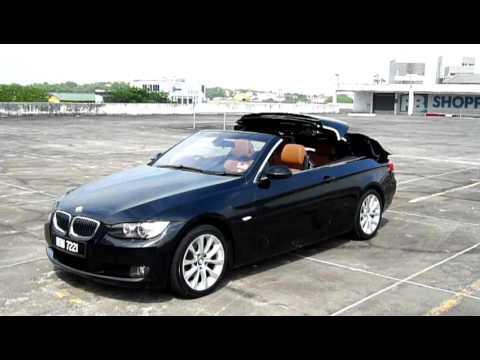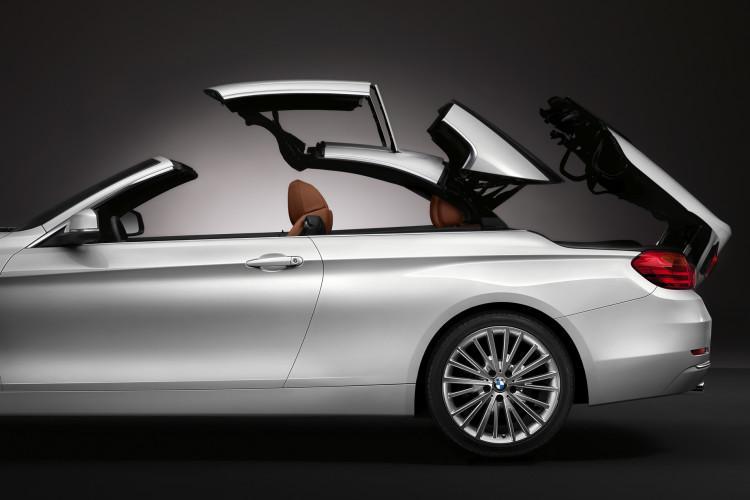The first image is the image on the left, the second image is the image on the right. Examine the images to the left and right. Is the description "Each image shows the entire length of a sports car with a convertible top that is in the act of being lowered." accurate? Answer yes or no. No. The first image is the image on the left, the second image is the image on the right. For the images displayed, is the sentence "An image shows brown rocky peaks behind a white convertible with its top partly extended." factually correct? Answer yes or no. No. 